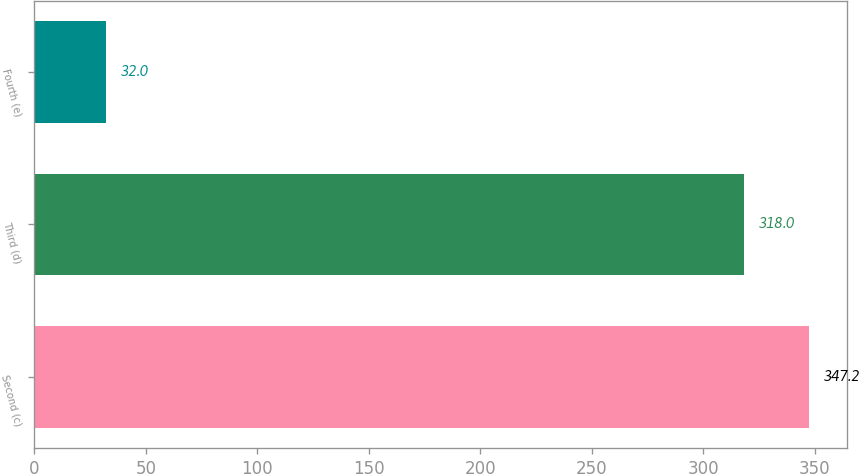<chart> <loc_0><loc_0><loc_500><loc_500><bar_chart><fcel>Second (c)<fcel>Third (d)<fcel>Fourth (e)<nl><fcel>347.2<fcel>318<fcel>32<nl></chart> 